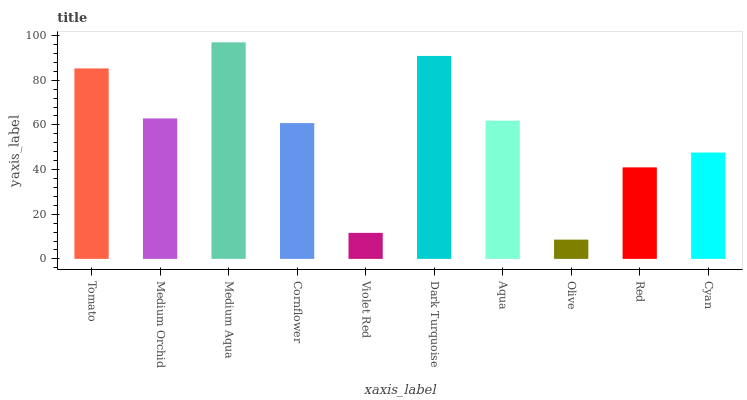Is Olive the minimum?
Answer yes or no. Yes. Is Medium Aqua the maximum?
Answer yes or no. Yes. Is Medium Orchid the minimum?
Answer yes or no. No. Is Medium Orchid the maximum?
Answer yes or no. No. Is Tomato greater than Medium Orchid?
Answer yes or no. Yes. Is Medium Orchid less than Tomato?
Answer yes or no. Yes. Is Medium Orchid greater than Tomato?
Answer yes or no. No. Is Tomato less than Medium Orchid?
Answer yes or no. No. Is Aqua the high median?
Answer yes or no. Yes. Is Cornflower the low median?
Answer yes or no. Yes. Is Olive the high median?
Answer yes or no. No. Is Tomato the low median?
Answer yes or no. No. 